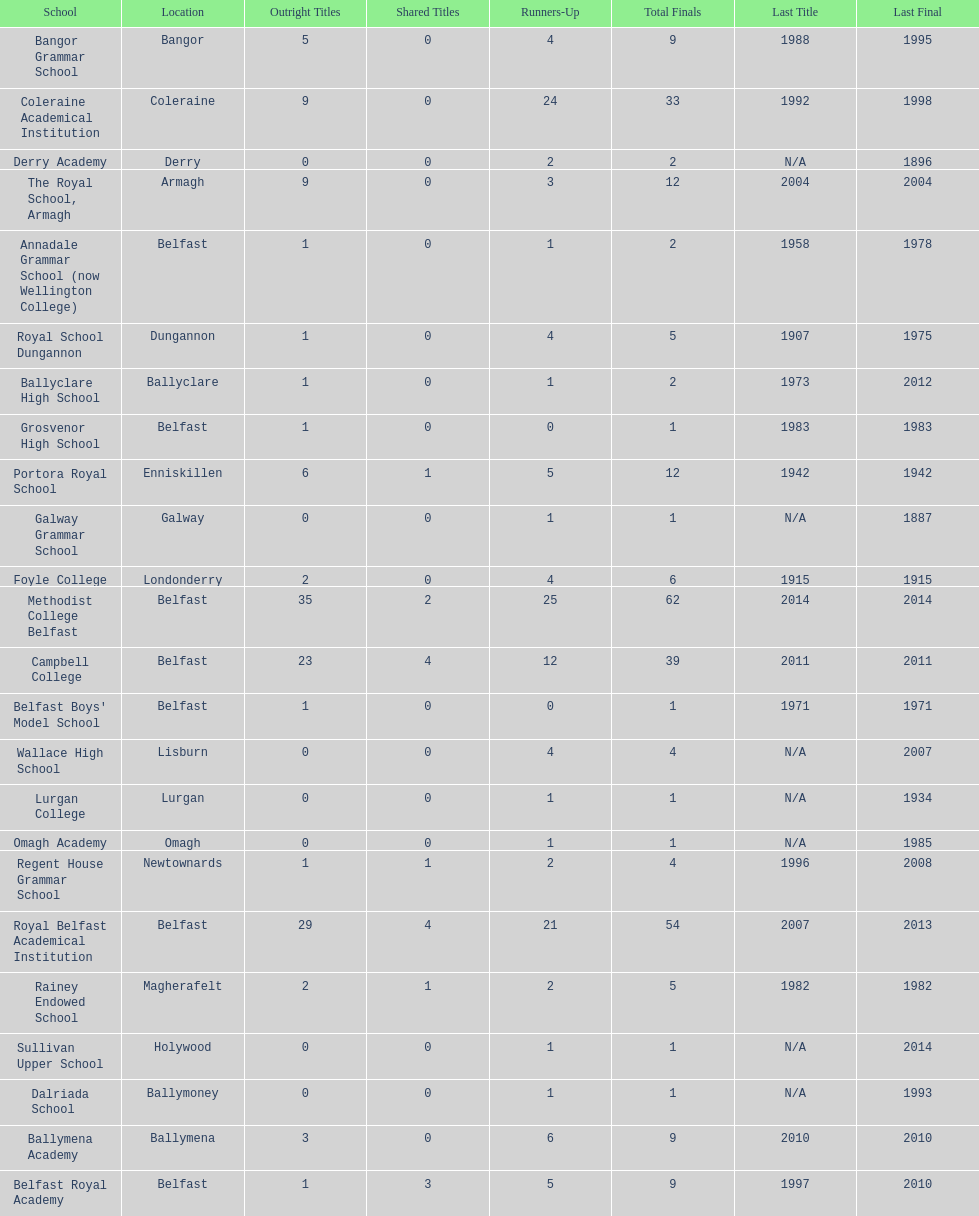How many schools have at least 5 outright titles? 7. 